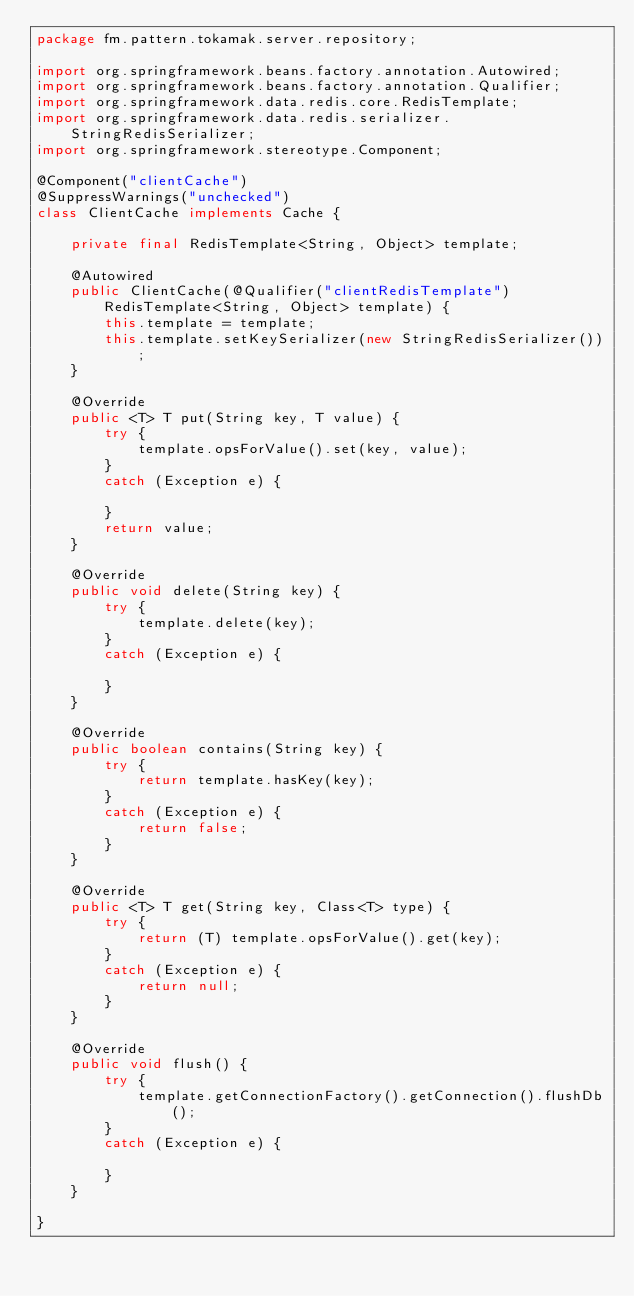Convert code to text. <code><loc_0><loc_0><loc_500><loc_500><_Java_>package fm.pattern.tokamak.server.repository;

import org.springframework.beans.factory.annotation.Autowired;
import org.springframework.beans.factory.annotation.Qualifier;
import org.springframework.data.redis.core.RedisTemplate;
import org.springframework.data.redis.serializer.StringRedisSerializer;
import org.springframework.stereotype.Component;

@Component("clientCache")
@SuppressWarnings("unchecked")
class ClientCache implements Cache {

	private final RedisTemplate<String, Object> template;

	@Autowired
	public ClientCache(@Qualifier("clientRedisTemplate") RedisTemplate<String, Object> template) {
		this.template = template;
		this.template.setKeySerializer(new StringRedisSerializer());
	}

	@Override
	public <T> T put(String key, T value) {
		try {
			template.opsForValue().set(key, value);
		}
		catch (Exception e) {

		}
		return value;
	}

	@Override
	public void delete(String key) {
		try {
			template.delete(key);
		}
		catch (Exception e) {

		}
	}

	@Override
	public boolean contains(String key) {
		try {
			return template.hasKey(key);
		}
		catch (Exception e) {
			return false;
		}
	}

	@Override
	public <T> T get(String key, Class<T> type) {
		try {
			return (T) template.opsForValue().get(key);
		}
		catch (Exception e) {
			return null;
		}
	}

	@Override
	public void flush() {
		try {
			template.getConnectionFactory().getConnection().flushDb();
		}
		catch (Exception e) {

		}
	}

}
</code> 